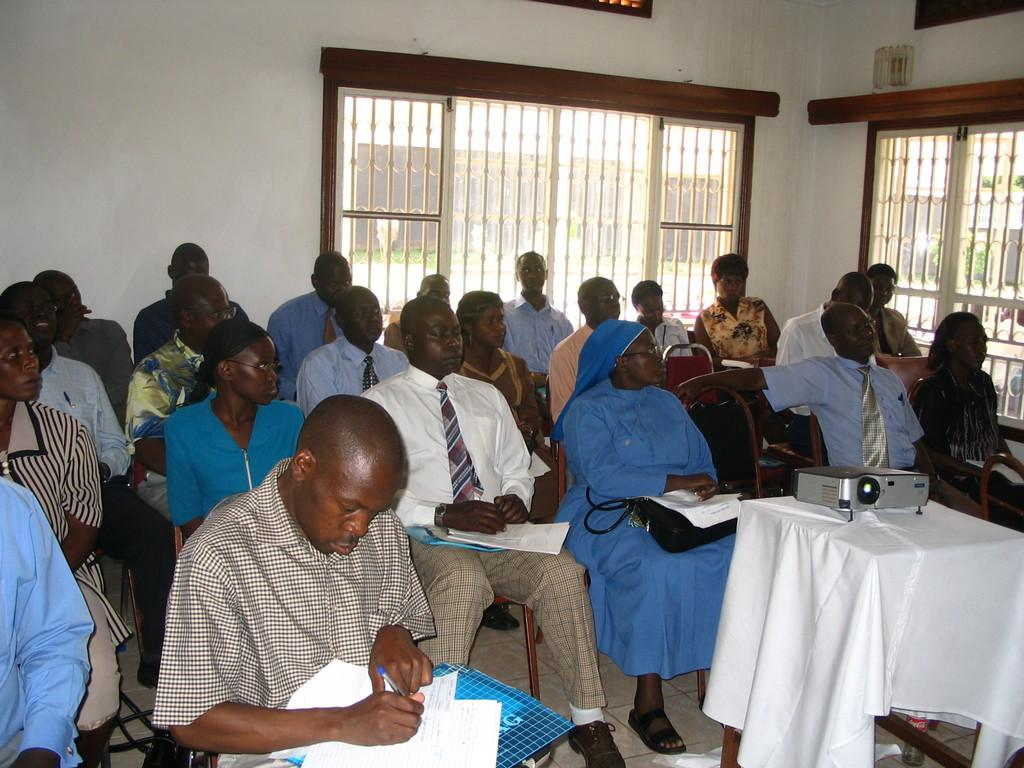How many people are in the image? There is a group of people in the image. What are the people doing in the image? The people are sitting on chairs. In which direction are the people looking? The people are looking to the right side. What can be seen behind the group of people? There is a window behind the group of people. Who is the owner of the can in the image? There is no can present in the image. What emotion is displayed by the people in the image? The provided facts do not mention any emotions or expressions of the people in the image. 